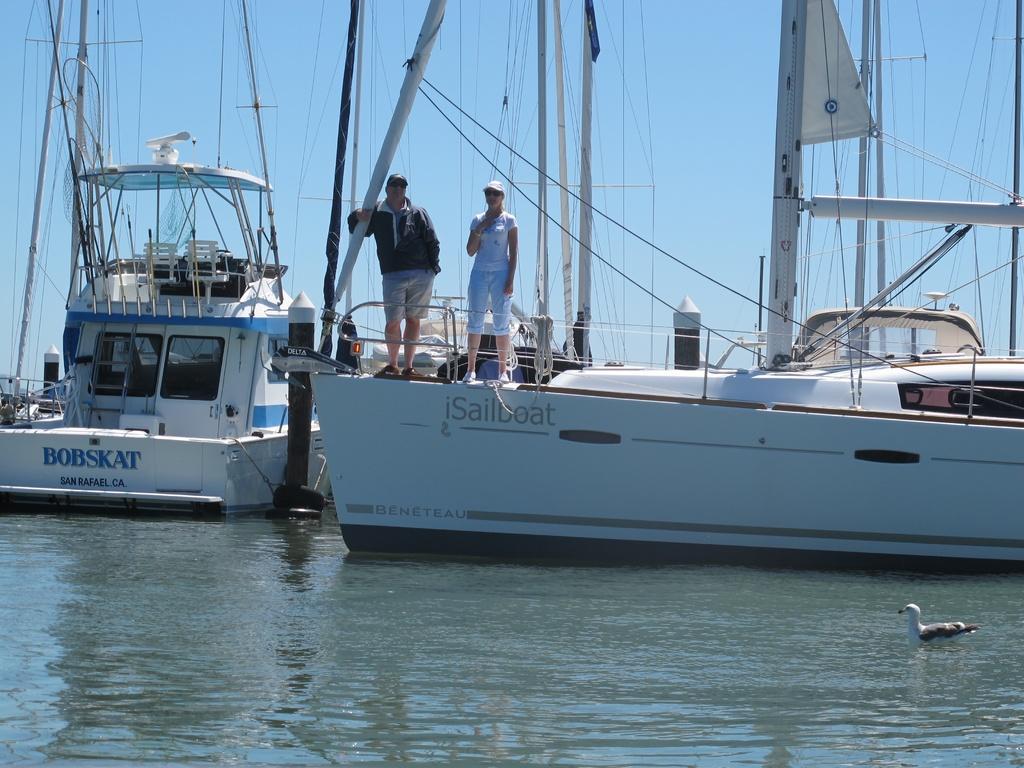Can you describe this image briefly? In this image, we can see people on the boats and are wearing caps. At the top, there is sky and at the bottom, there is a bird on the water. 